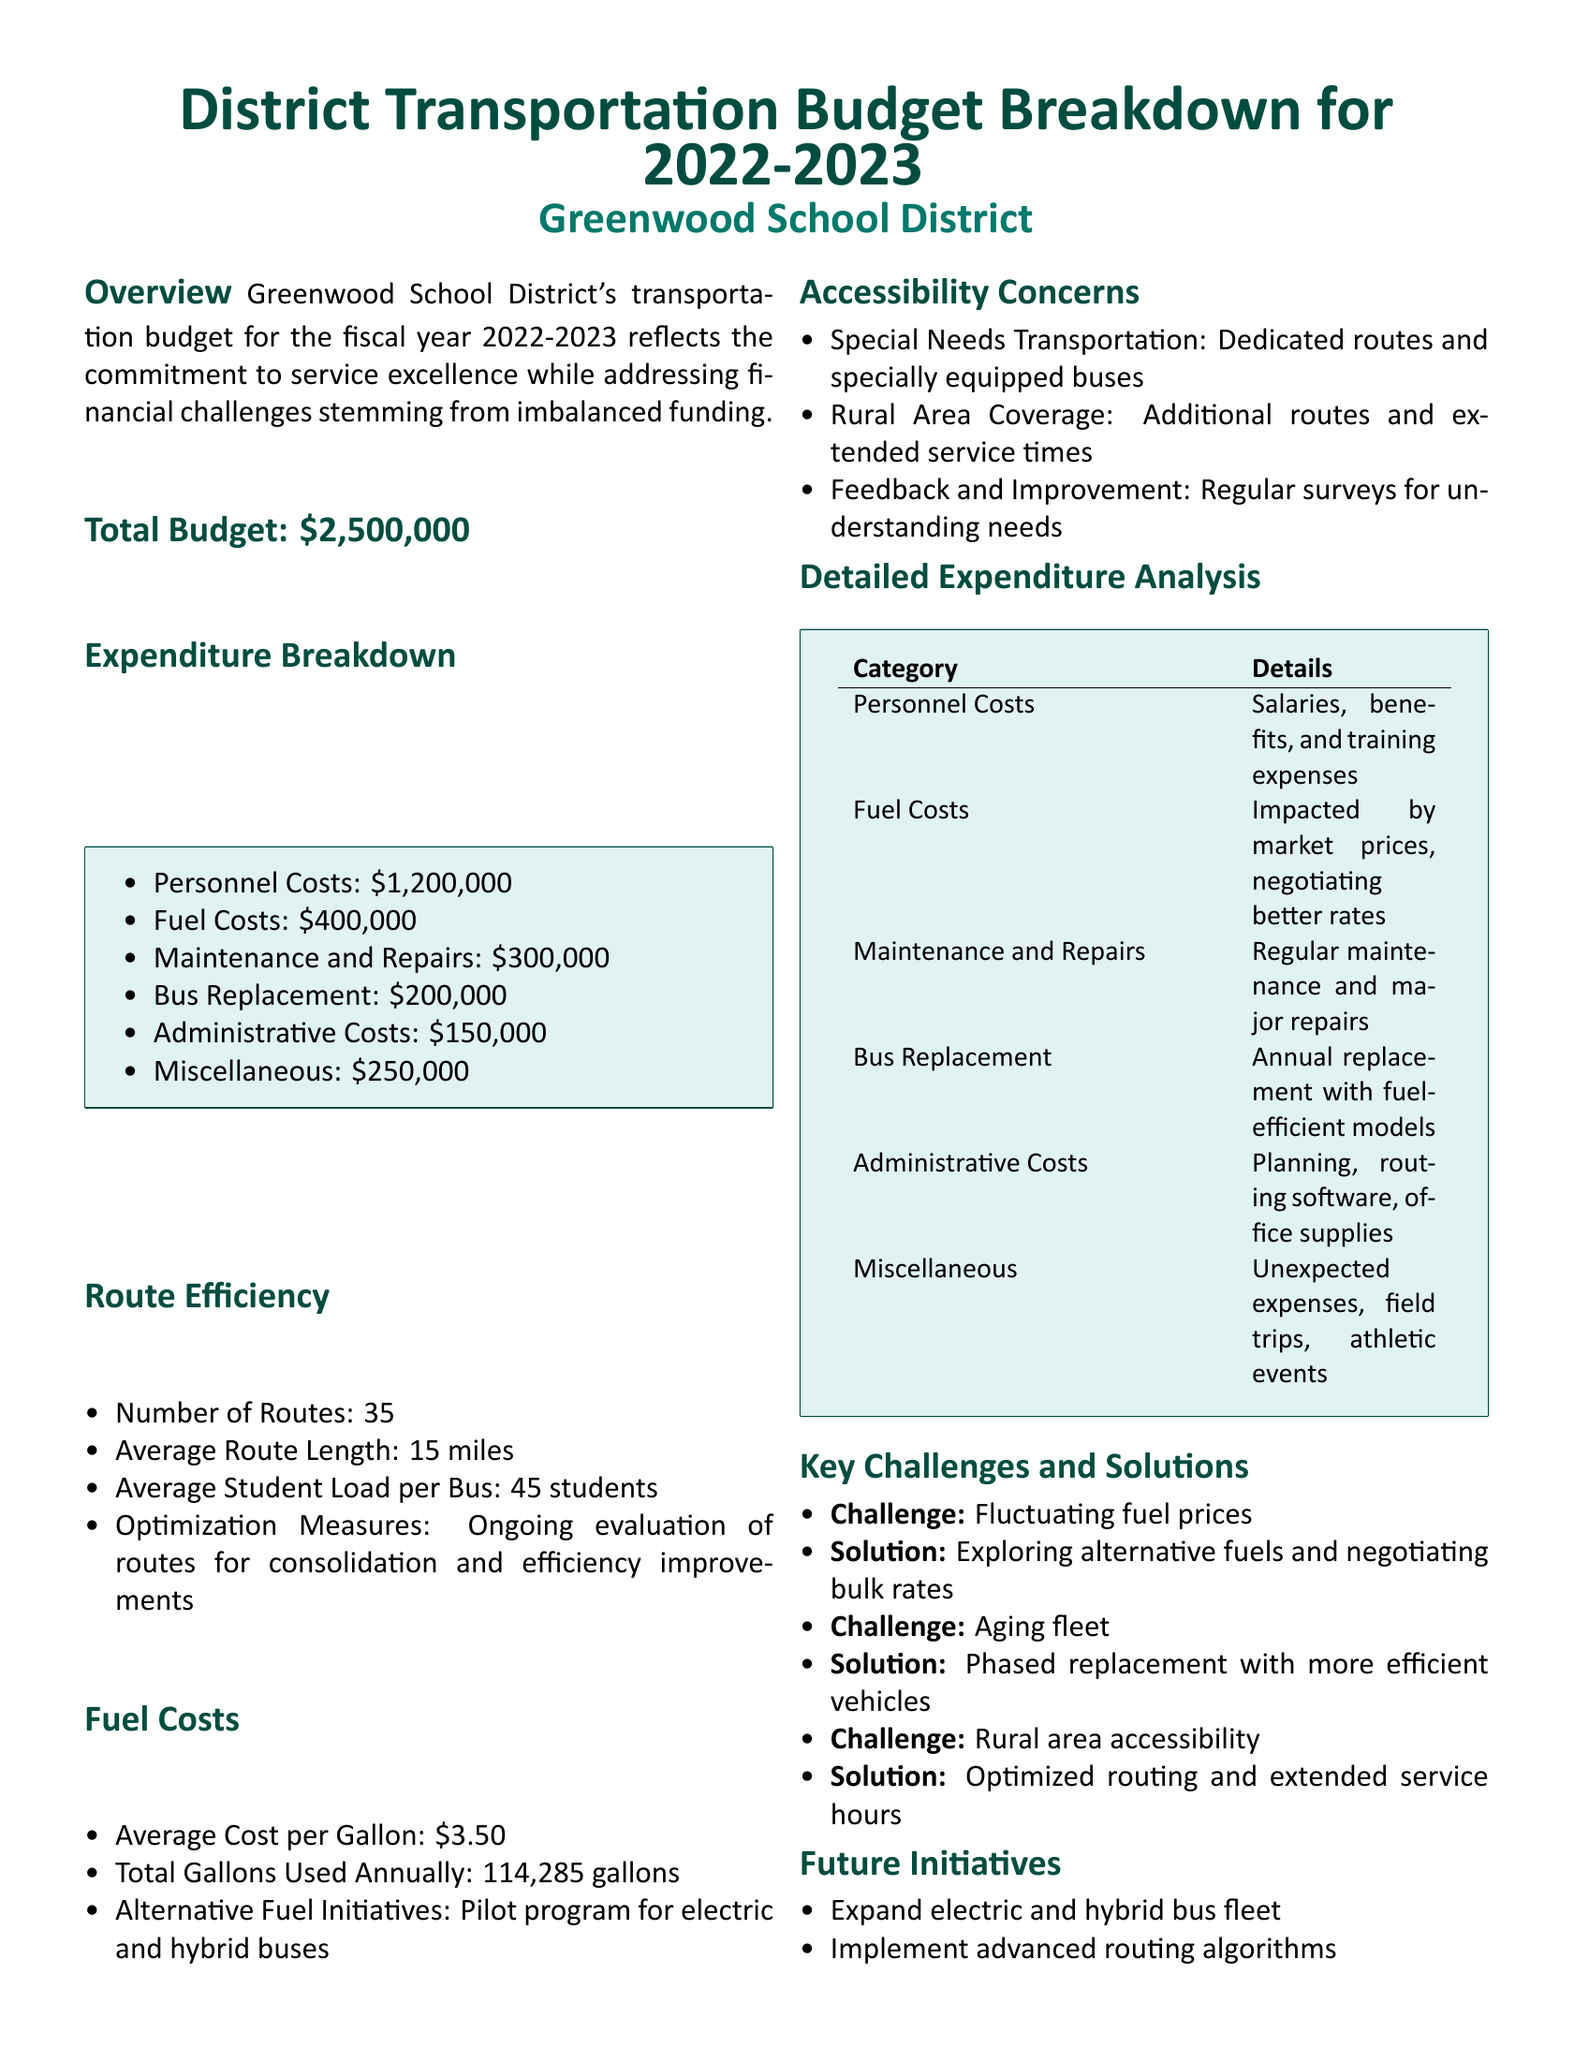What is the total budget? The total budget is stated clearly in the document as the overall funding allocated for transportation in the district.
Answer: $2,500,000 How much is allocated for fuel costs? The document specifies the amount designated for fuel as one of the key expenditure categories.
Answer: $400,000 What is the average student load per bus? This information is included in the route efficiency section, indicating how many students a bus typically carries.
Answer: 45 students What is the average cost per gallon of fuel? The document provides details about fuel expenses, including the average cost per gallon.
Answer: $3.50 What effort is being made to improve accessibility in rural areas? The document outlines specific measures taken to ensure transportation services to rural areas.
Answer: Additional routes and extended service times What is the challenge related to fuel prices? The document lists challenges faced by the district regarding transportation, including financial concerns.
Answer: Fluctuating fuel prices How many routes are there in the district? This number is detailed under the route efficiency section, which gives an overview of the transportation network.
Answer: 35 What program is being piloted for fuel alternatives? The document mentions specific initiatives being considered for more sustainable transportation solutions.
Answer: Pilot program for electric and hybrid buses What are the administrative costs? This figure is included in the expenditure breakdown, reflecting how funds are allocated for administrative purposes.
Answer: $150,000 